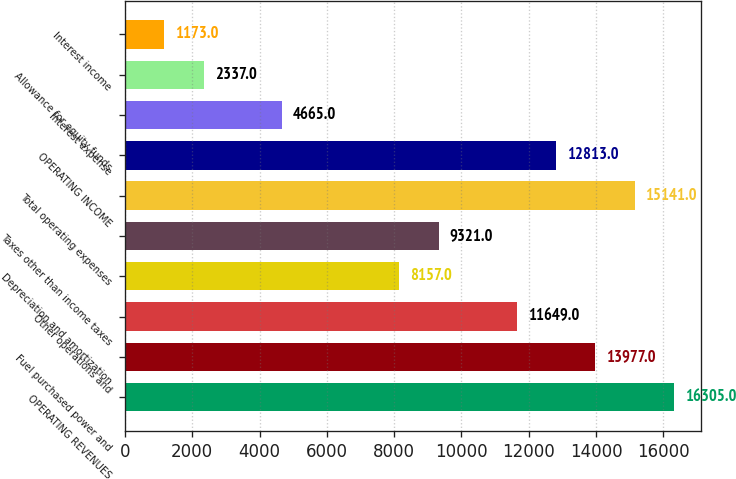<chart> <loc_0><loc_0><loc_500><loc_500><bar_chart><fcel>OPERATING REVENUES<fcel>Fuel purchased power and<fcel>Other operations and<fcel>Depreciation and amortization<fcel>Taxes other than income taxes<fcel>Total operating expenses<fcel>OPERATING INCOME<fcel>Interest expense<fcel>Allowance for equity funds<fcel>Interest income<nl><fcel>16305<fcel>13977<fcel>11649<fcel>8157<fcel>9321<fcel>15141<fcel>12813<fcel>4665<fcel>2337<fcel>1173<nl></chart> 